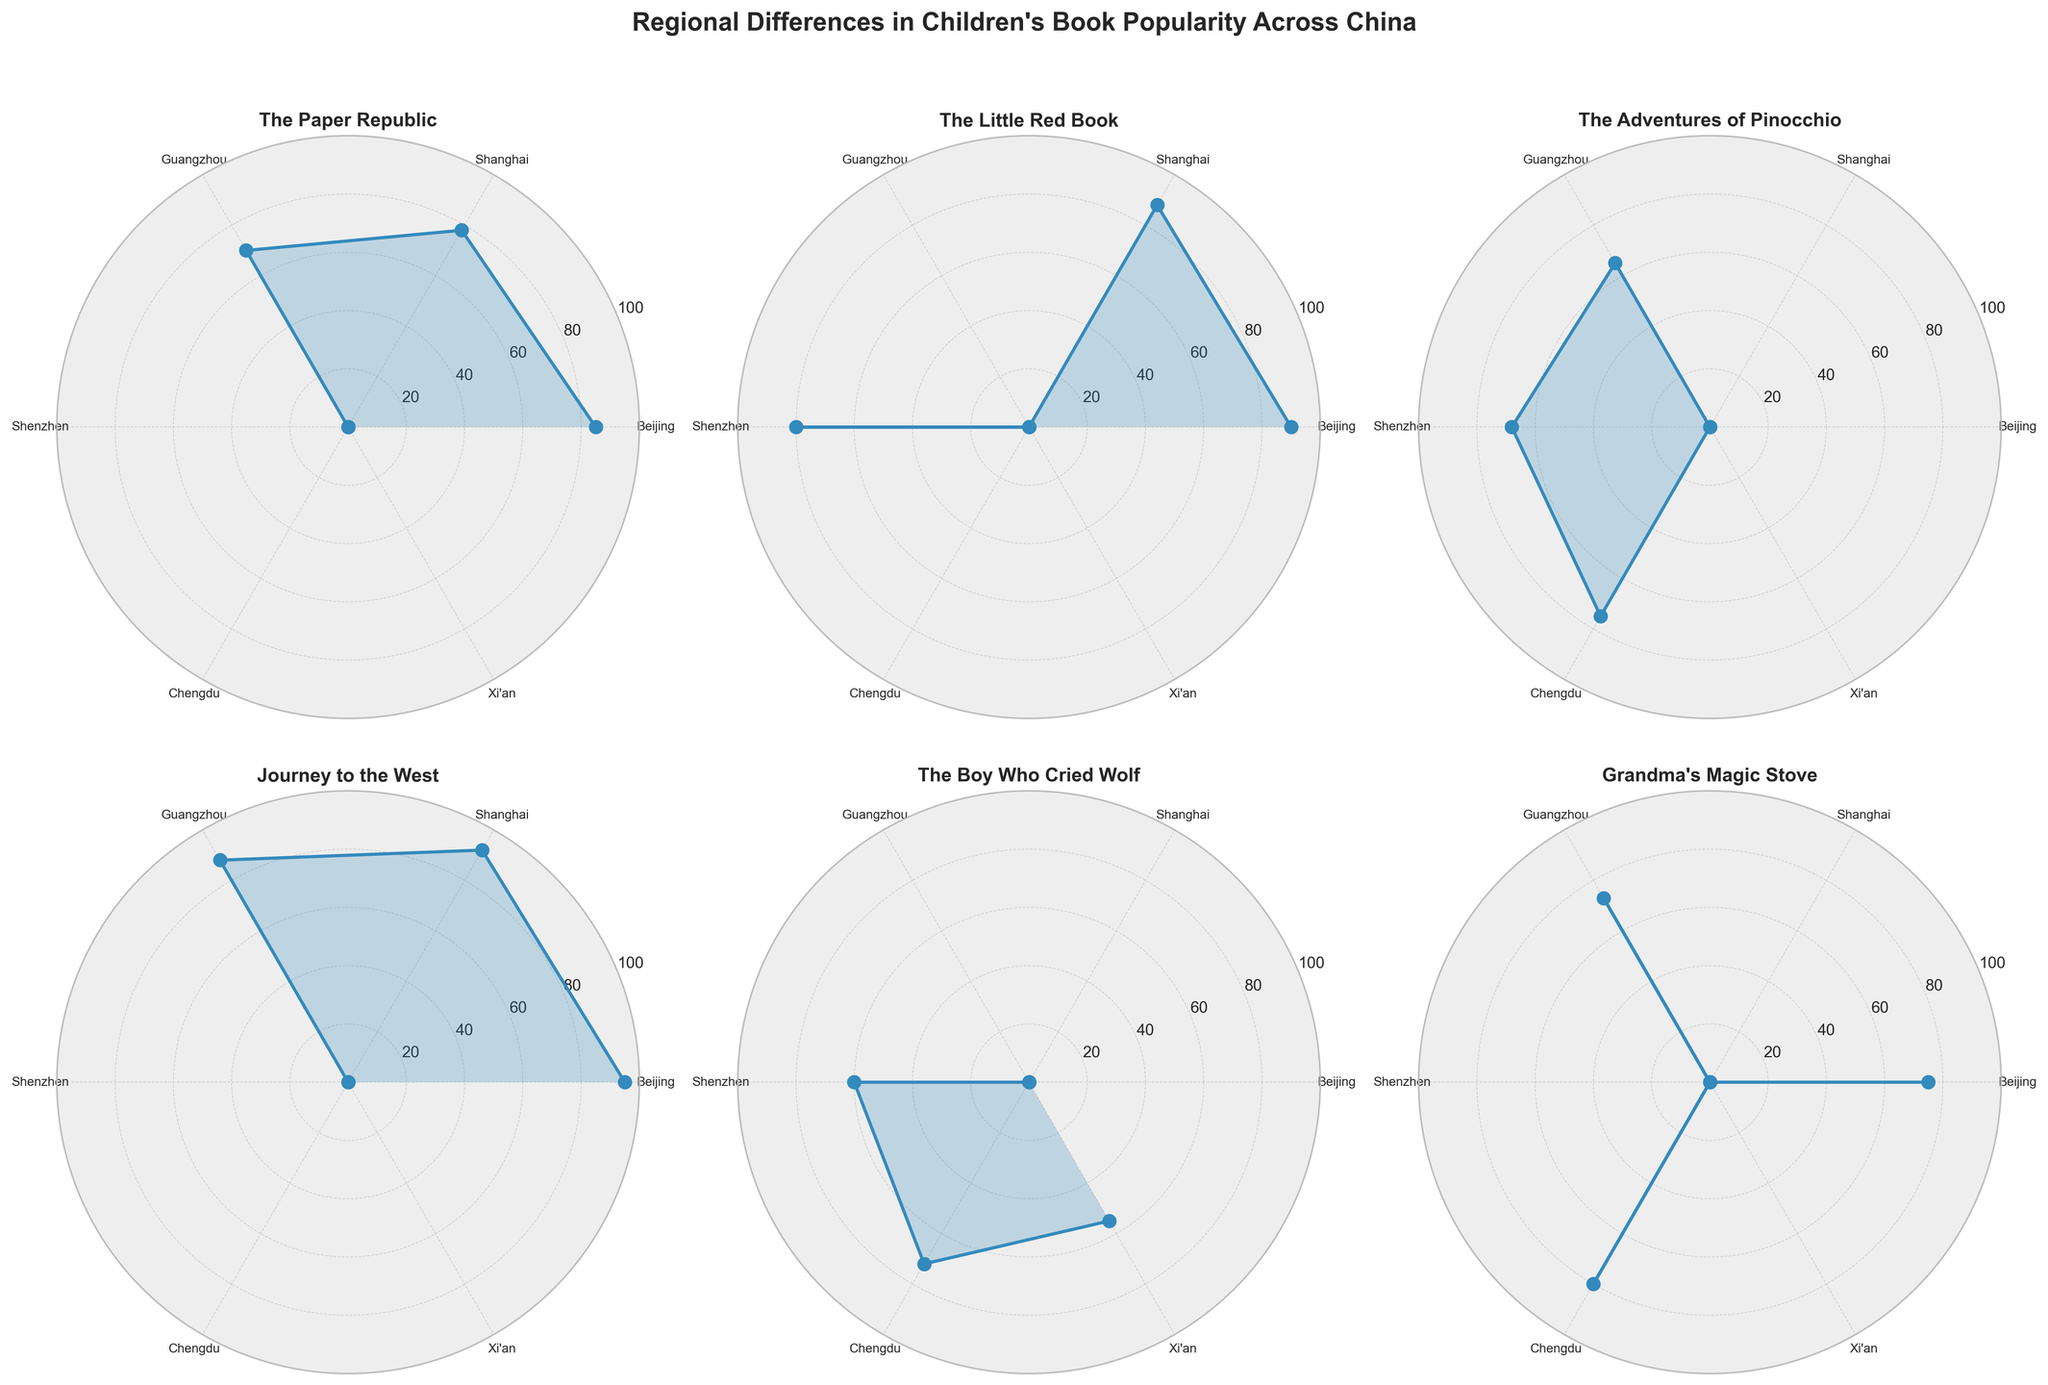What's the title of the figure? The title is usually positioned above the figure. Look at the top center part of the figure where the title is typically situated.
Answer: "Regional Differences in Children's Book Popularity Across China" Which book title has the highest peak popularity? Identify the subplots for each book title and compare the highest data points in each plot. "Journey to the West" has a peak at 95 (Beijing).
Answer: "Journey to the West" In which city is "The Little Red Book" most popular? Find the subplot for "The Little Red Book" and observe the data points to see which one has the highest popularity score. Shanghai has a score of 88.
Answer: "Beijing" Which regions have the lowest popularity for "The Boy Who Cried Wolf"? Find the subplot for "The Boy Who Cried Wolf" and look for the data points with the lowest values. The lowest values are in Shenzhen (60) and Xi'an (55).
Answer: "Xi'an" Compare the popularity of "Grandma's Magic Stove" in Beijing and Guangzhou. Locate the subplot for "Grandma's Magic Stove", then compare data points for Beijing (75) and Guangzhou (73).
Answer: Beijing has a popularity of 75, and Guangzhou has 73 What is the average popularity of "The Adventures of Pinocchio"? First, identify the data points for "The Adventures of Pinocchio" (Guangzhou: 65, Shenzhen: 68, Chengdu: 75). Compute the average: (65 + 68 + 75) / 3 = 68.
Answer: 68 Which book shows a more consistent popularity across the cities? "The Paper Republic" or "Journey to the West"? Compare the two subplots' data points and observe the variability. "The Paper Republic" varies more (85, 78, 70) than "Journey to the West" (95, 92, 88).
Answer: "Journey to the West" How does "The Boy Who Cried Wolf" perform in Chengdu compared to Xi'an? Review the subplot for "The Boy Who Cried Wolf" and compare Chengdu (72) with Xi'an (55).
Answer: Chengdu has a popularity of 72, which is higher than Xi'an's 55 Which book has the smallest variation in popularity across regions? For each subplot, calculate the deviation range and identify which one has the least deviation. "Journey to the West" has the smallest variation (95-88=7).
Answer: "Journey to the West" What is the combined popularity of "The Little Red Book" across all regions? Sum up the popularity values from the different regions for "The Little Red Book" (90 + 88 + 80). The total is 258.
Answer: 258 